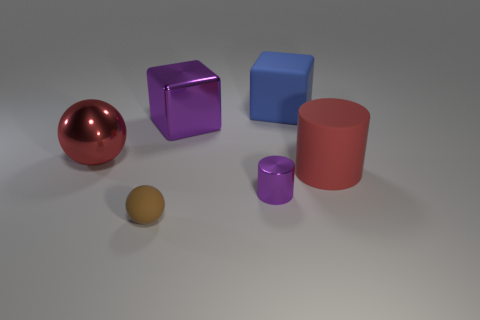What materials do the objects in the image seem to be made of? The objects in the image appear to have different materials. The sphere on the left has a reflective surface suggesting it's metallic, the two cubes look plastic with matte finishes, one in purple and one in blue, while the cylinders have a rubber-like appearance, with the larger one in red and the smaller one in purple. The smaller sphere has a matte finish, which could imply a clay or plastic material. 